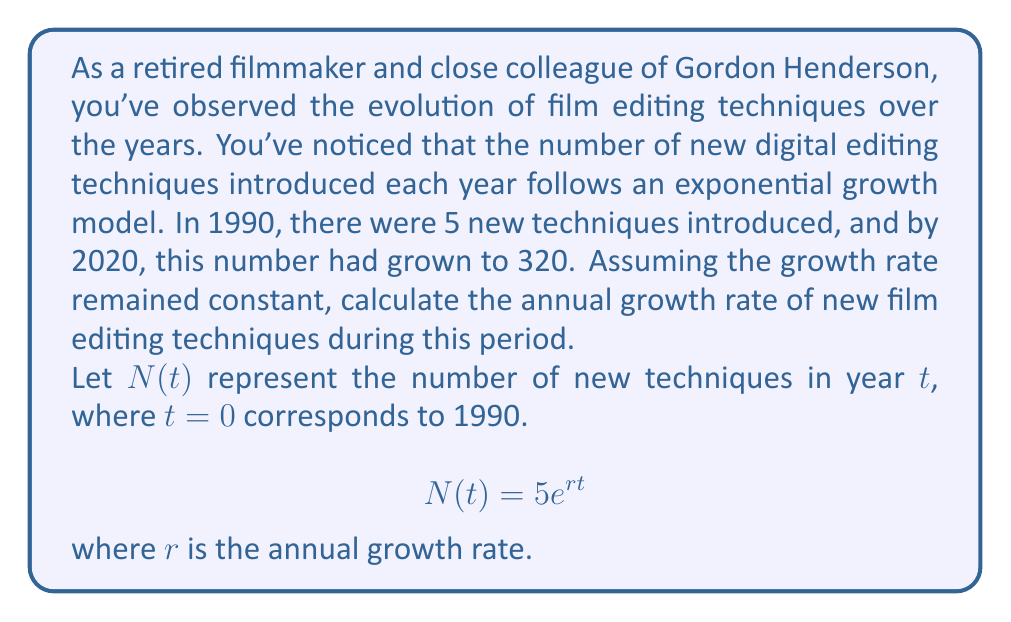What is the answer to this math problem? To solve this problem, we'll use the exponential growth formula:

$$N(t) = N_0e^{rt}$$

Where:
$N(t)$ is the number of new techniques at time $t$
$N_0$ is the initial number of techniques (5 in 1990)
$r$ is the annual growth rate
$t$ is the time in years since 1990

We know:
$N_0 = 5$
$N(30) = 320$ (as 2020 is 30 years after 1990)
$t = 30$

Let's substitute these values into the equation:

$$320 = 5e^{r(30)}$$

Now, let's solve for $r$:

1) Divide both sides by 5:
   $$64 = e^{30r}$$

2) Take the natural logarithm of both sides:
   $$\ln(64) = 30r$$

3) Solve for $r$:
   $$r = \frac{\ln(64)}{30}$$

4) Calculate the value:
   $$r = \frac{4.1588833}{30} \approx 0.1386$$

5) Convert to a percentage:
   $$0.1386 \times 100\% \approx 13.86\%$$

Therefore, the annual growth rate of new film editing techniques is approximately 13.86%.
Answer: 13.86% 